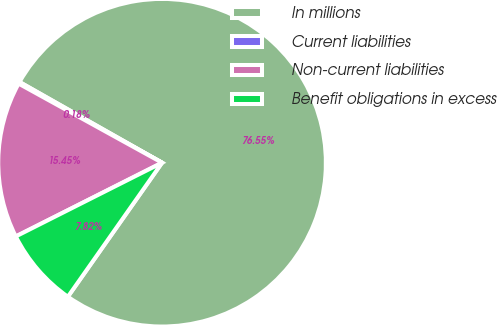<chart> <loc_0><loc_0><loc_500><loc_500><pie_chart><fcel>In millions<fcel>Current liabilities<fcel>Non-current liabilities<fcel>Benefit obligations in excess<nl><fcel>76.55%<fcel>0.18%<fcel>15.45%<fcel>7.82%<nl></chart> 